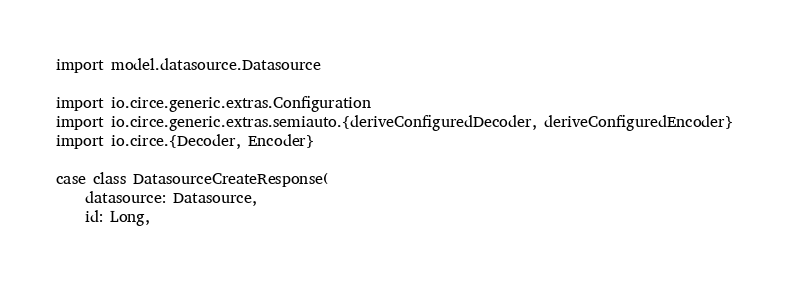<code> <loc_0><loc_0><loc_500><loc_500><_Scala_>
import model.datasource.Datasource

import io.circe.generic.extras.Configuration
import io.circe.generic.extras.semiauto.{deriveConfiguredDecoder, deriveConfiguredEncoder}
import io.circe.{Decoder, Encoder}

case class DatasourceCreateResponse(
    datasource: Datasource,
    id: Long,</code> 